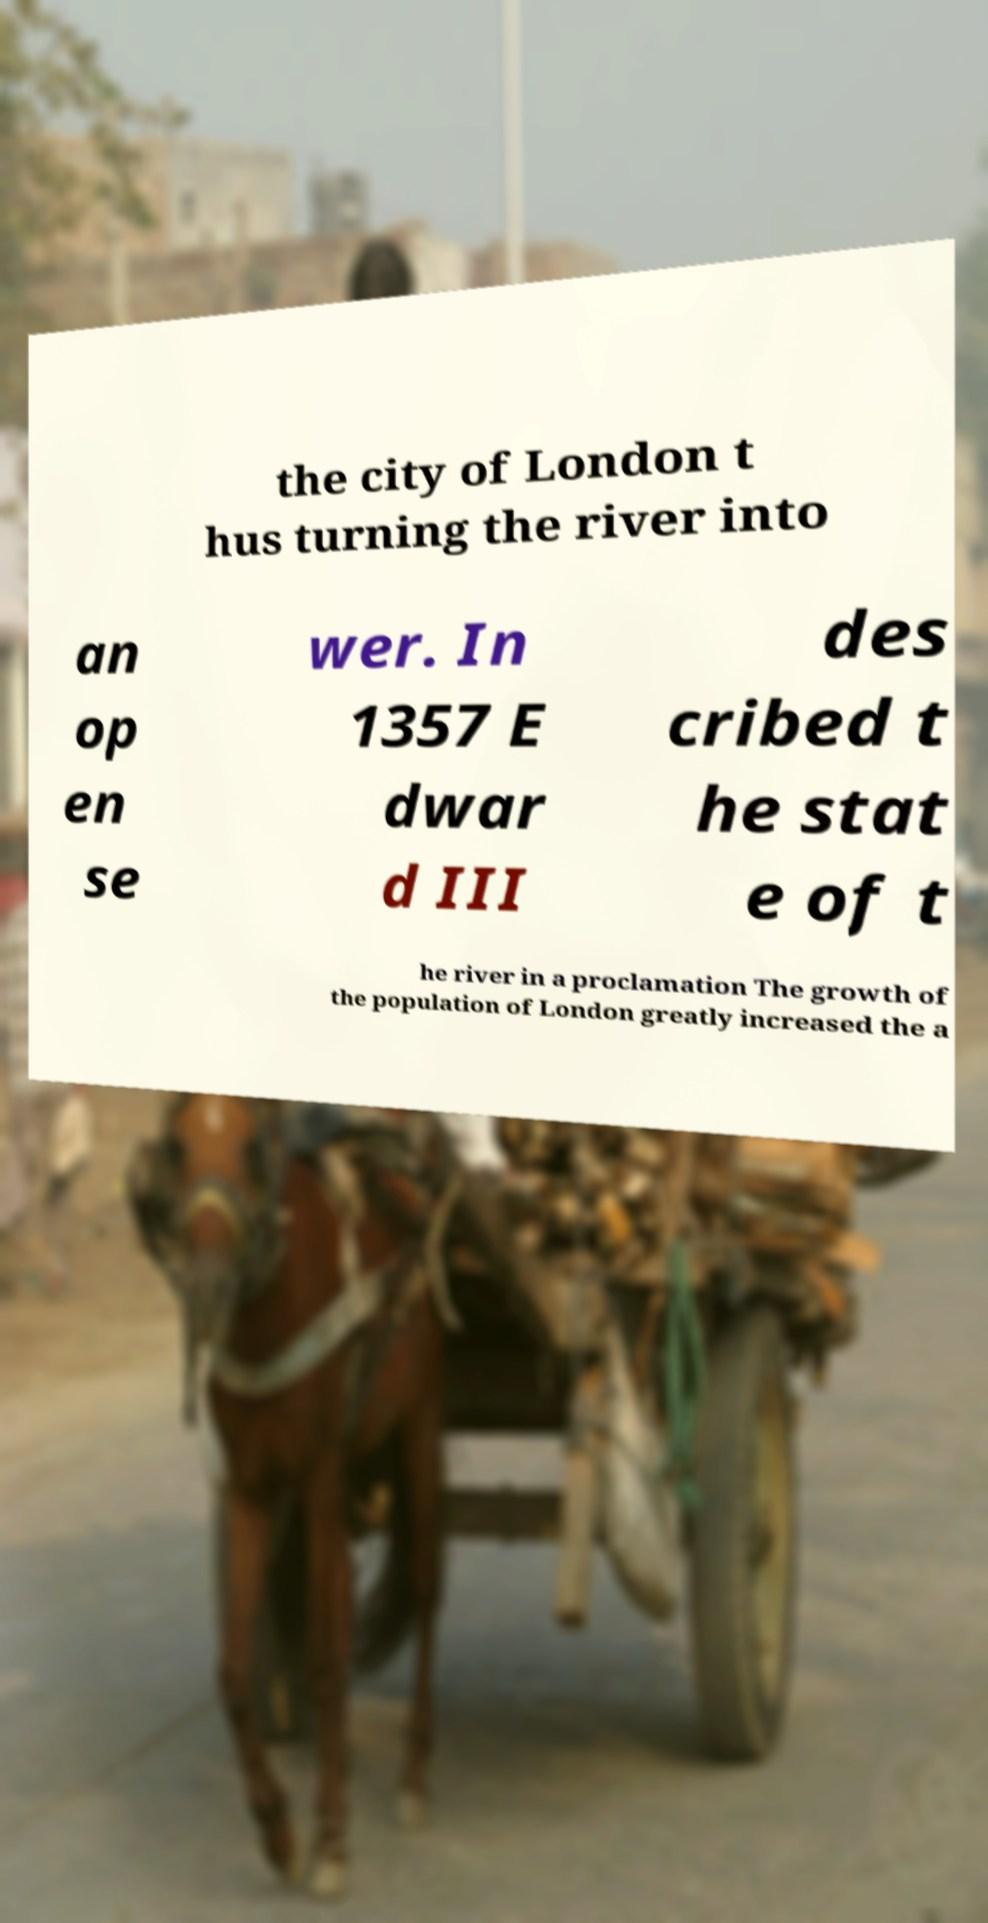I need the written content from this picture converted into text. Can you do that? the city of London t hus turning the river into an op en se wer. In 1357 E dwar d III des cribed t he stat e of t he river in a proclamation The growth of the population of London greatly increased the a 